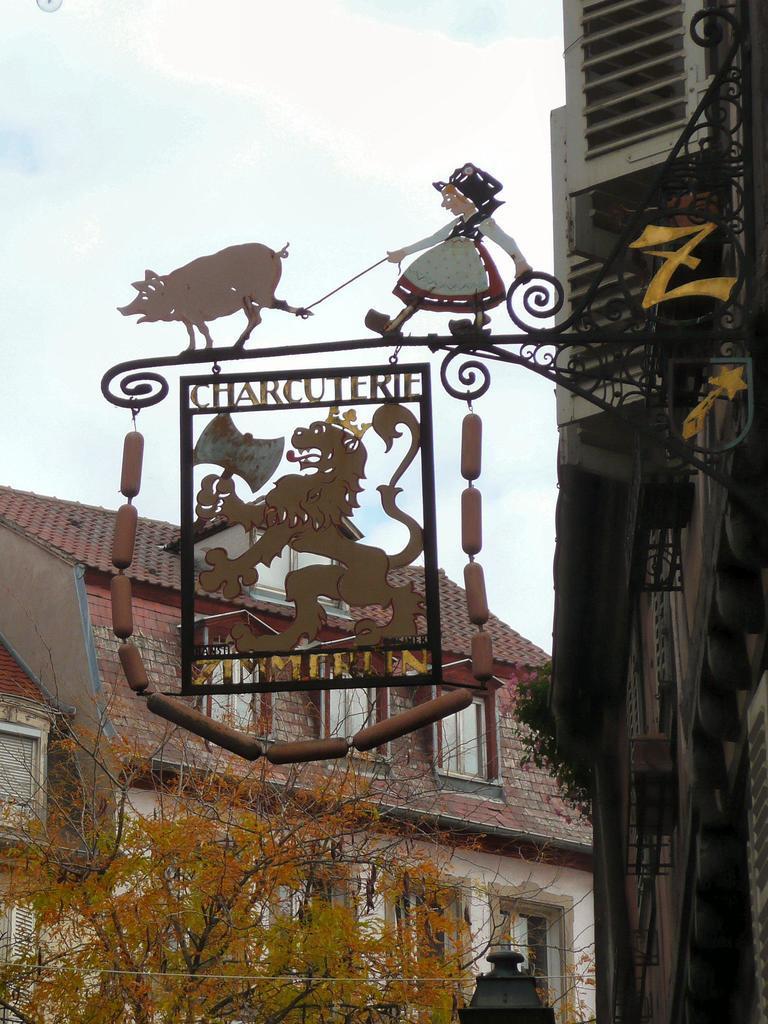Can you describe this image briefly? In this image, I can see a name board to an iron grille. There are buildings and trees. In the background, there is the sky. 